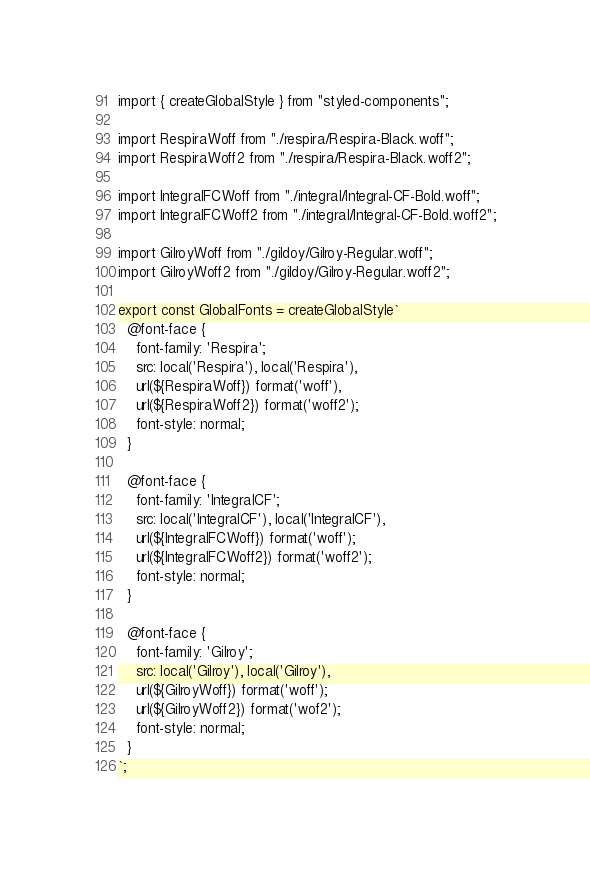<code> <loc_0><loc_0><loc_500><loc_500><_JavaScript_>import { createGlobalStyle } from "styled-components";

import RespiraWoff from "./respira/Respira-Black.woff";
import RespiraWoff2 from "./respira/Respira-Black.woff2";

import IntegralFCWoff from "./integral/Integral-CF-Bold.woff";
import IntegralFCWoff2 from "./integral/Integral-CF-Bold.woff2";

import GilroyWoff from "./gildoy/Gilroy-Regular.woff";
import GilroyWoff2 from "./gildoy/Gilroy-Regular.woff2";

export const GlobalFonts = createGlobalStyle`
  @font-face {
    font-family: 'Respira';
    src: local('Respira'), local('Respira'),
    url(${RespiraWoff}) format('woff'),
    url(${RespiraWoff2}) format('woff2');
    font-style: normal;
  }

  @font-face {
    font-family: 'IntegralCF';
    src: local('IntegralCF'), local('IntegralCF'),
    url(${IntegralFCWoff}) format('woff');
    url(${IntegralFCWoff2}) format('woff2');
    font-style: normal;
  }

  @font-face {
    font-family: 'Gilroy';
    src: local('Gilroy'), local('Gilroy'),
    url(${GilroyWoff}) format('woff');
    url(${GilroyWoff2}) format('wof2');
    font-style: normal;
  }
`;
</code> 